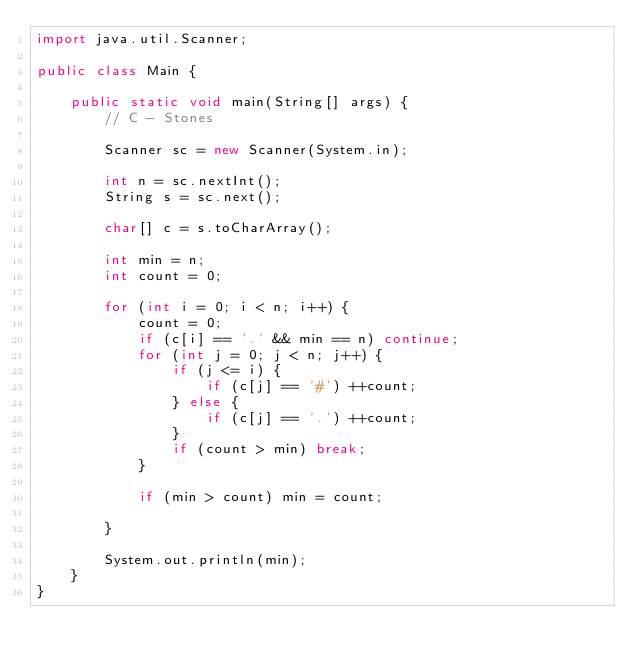<code> <loc_0><loc_0><loc_500><loc_500><_Java_>import java.util.Scanner;

public class Main {

    public static void main(String[] args) {
        // C - Stones

        Scanner sc = new Scanner(System.in);

        int n = sc.nextInt();
        String s = sc.next();
        
        char[] c = s.toCharArray();
        
        int min = n;
        int count = 0;
        
        for (int i = 0; i < n; i++) {
            count = 0;
            if (c[i] == '.' && min == n) continue;
            for (int j = 0; j < n; j++) {
                if (j <= i) {
                    if (c[j] == '#') ++count;
                } else {
                    if (c[j] == '.') ++count;
                }
                if (count > min) break;
            }
            
            if (min > count) min = count;

        }
        
        System.out.println(min);
    }
}</code> 